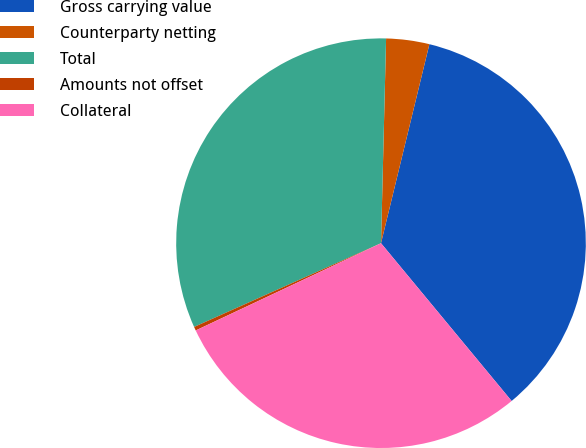Convert chart to OTSL. <chart><loc_0><loc_0><loc_500><loc_500><pie_chart><fcel>Gross carrying value<fcel>Counterparty netting<fcel>Total<fcel>Amounts not offset<fcel>Collateral<nl><fcel>35.2%<fcel>3.4%<fcel>32.1%<fcel>0.3%<fcel>29.0%<nl></chart> 